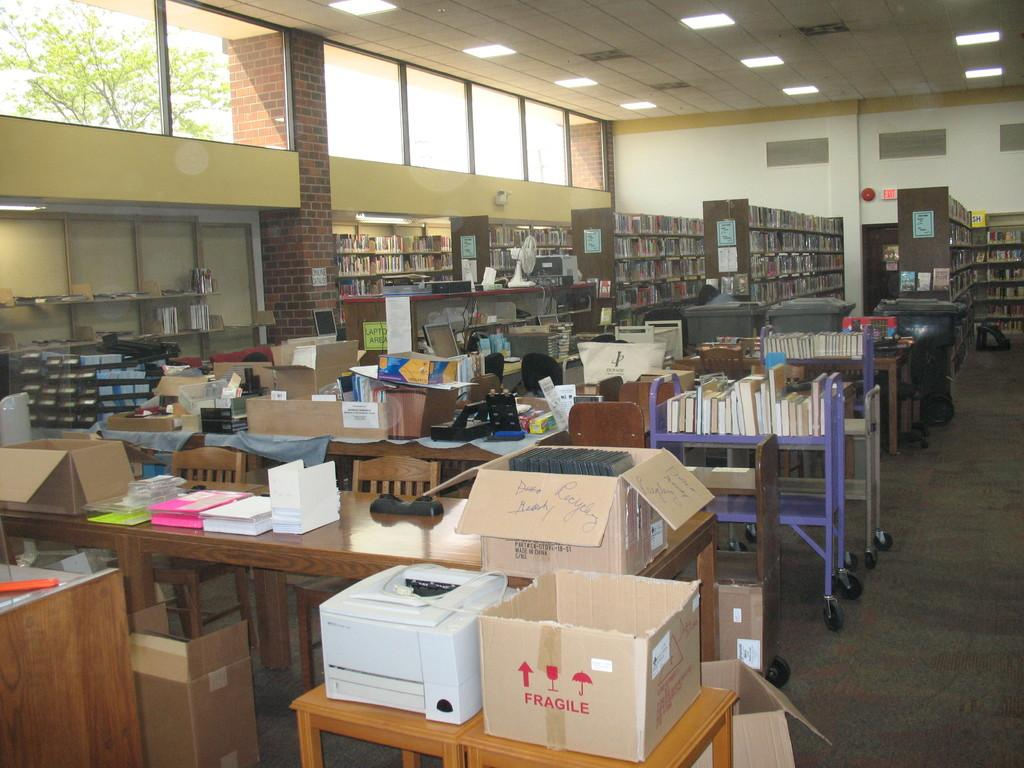What type of furniture is present in the image? There is a shelf and a desk in the image. What is located on the shelf? There are many things on the shelf. What is located on the desk? There are some things on the desk. How many kittens are playing on the railway in the image? There is no railway or kittens present in the image. What color is the orange on the shelf in the image? There is no orange present in the image. 